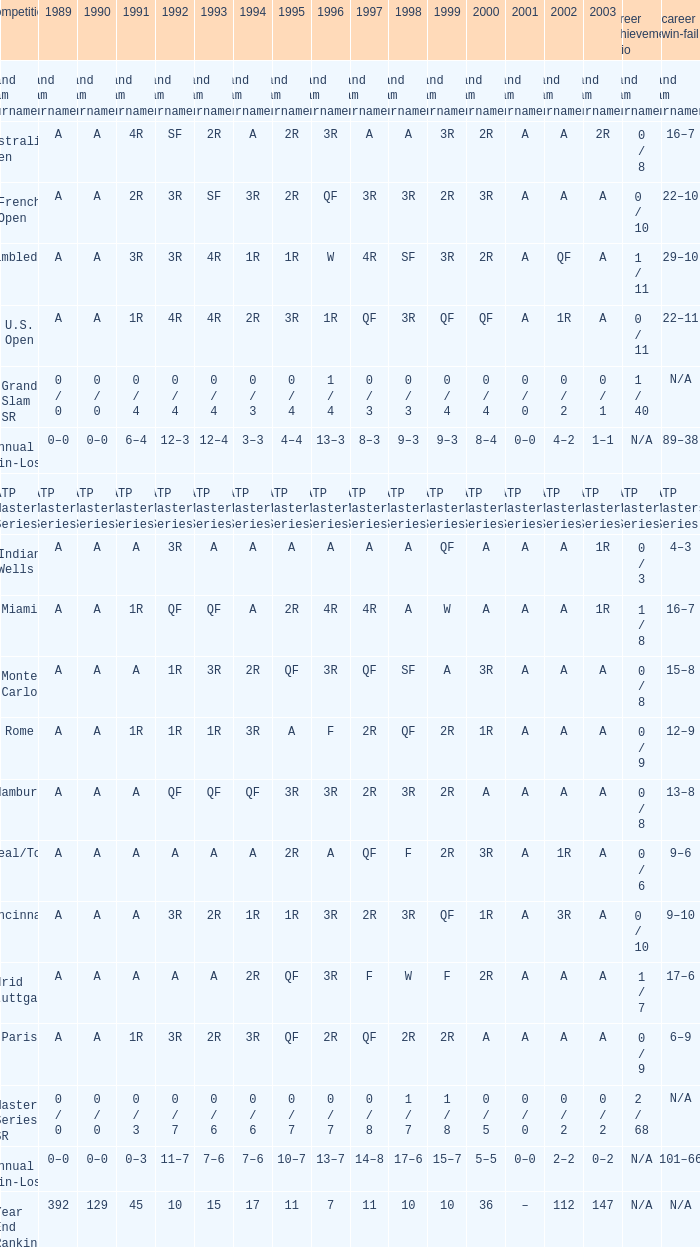What is the value in 1997 when the value in 1989 is A, 1995 is QF, 1996 is 3R and the career SR is 0 / 8? QF. 